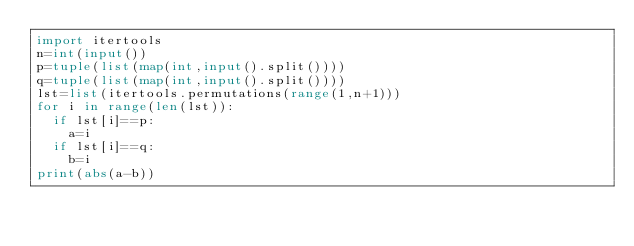Convert code to text. <code><loc_0><loc_0><loc_500><loc_500><_Python_>import itertools
n=int(input())
p=tuple(list(map(int,input().split())))
q=tuple(list(map(int,input().split())))
lst=list(itertools.permutations(range(1,n+1)))
for i in range(len(lst)):
  if lst[i]==p:
    a=i
  if lst[i]==q:
    b=i
print(abs(a-b))
</code> 